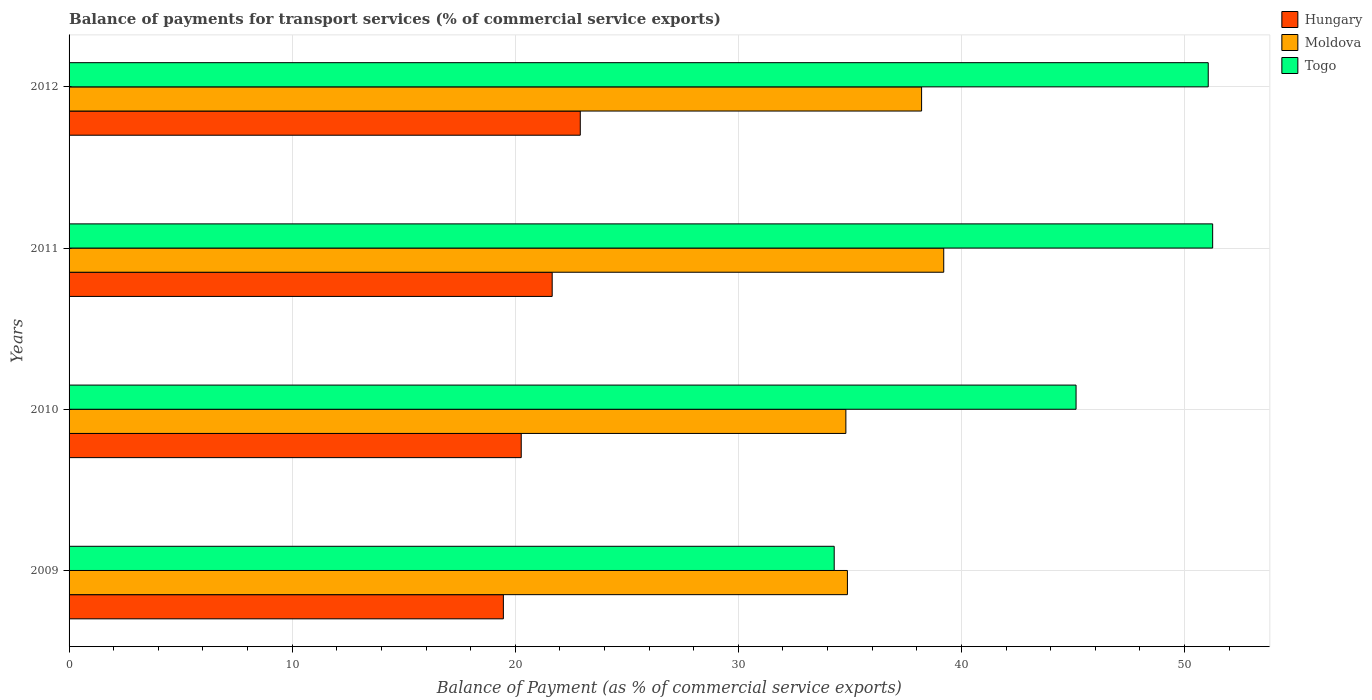How many different coloured bars are there?
Make the answer very short. 3. How many groups of bars are there?
Provide a short and direct response. 4. Are the number of bars per tick equal to the number of legend labels?
Your answer should be very brief. Yes. What is the label of the 1st group of bars from the top?
Your answer should be very brief. 2012. What is the balance of payments for transport services in Moldova in 2011?
Give a very brief answer. 39.21. Across all years, what is the maximum balance of payments for transport services in Hungary?
Offer a very short reply. 22.92. Across all years, what is the minimum balance of payments for transport services in Hungary?
Offer a very short reply. 19.47. In which year was the balance of payments for transport services in Hungary maximum?
Offer a very short reply. 2012. In which year was the balance of payments for transport services in Togo minimum?
Offer a terse response. 2009. What is the total balance of payments for transport services in Togo in the graph?
Provide a short and direct response. 181.76. What is the difference between the balance of payments for transport services in Togo in 2009 and that in 2011?
Keep it short and to the point. -16.96. What is the difference between the balance of payments for transport services in Hungary in 2010 and the balance of payments for transport services in Togo in 2012?
Your answer should be compact. -30.8. What is the average balance of payments for transport services in Togo per year?
Ensure brevity in your answer.  45.44. In the year 2009, what is the difference between the balance of payments for transport services in Hungary and balance of payments for transport services in Togo?
Your answer should be compact. -14.83. In how many years, is the balance of payments for transport services in Togo greater than 30 %?
Give a very brief answer. 4. What is the ratio of the balance of payments for transport services in Moldova in 2011 to that in 2012?
Offer a very short reply. 1.03. Is the difference between the balance of payments for transport services in Hungary in 2009 and 2012 greater than the difference between the balance of payments for transport services in Togo in 2009 and 2012?
Provide a succinct answer. Yes. What is the difference between the highest and the second highest balance of payments for transport services in Togo?
Make the answer very short. 0.2. What is the difference between the highest and the lowest balance of payments for transport services in Moldova?
Give a very brief answer. 4.39. In how many years, is the balance of payments for transport services in Togo greater than the average balance of payments for transport services in Togo taken over all years?
Ensure brevity in your answer.  2. Is the sum of the balance of payments for transport services in Hungary in 2010 and 2011 greater than the maximum balance of payments for transport services in Moldova across all years?
Your answer should be very brief. Yes. What does the 3rd bar from the top in 2010 represents?
Provide a short and direct response. Hungary. What does the 2nd bar from the bottom in 2012 represents?
Your answer should be compact. Moldova. Is it the case that in every year, the sum of the balance of payments for transport services in Moldova and balance of payments for transport services in Togo is greater than the balance of payments for transport services in Hungary?
Your answer should be very brief. Yes. Are all the bars in the graph horizontal?
Give a very brief answer. Yes. Does the graph contain any zero values?
Provide a short and direct response. No. Where does the legend appear in the graph?
Keep it short and to the point. Top right. How many legend labels are there?
Your answer should be compact. 3. What is the title of the graph?
Offer a very short reply. Balance of payments for transport services (% of commercial service exports). Does "Tuvalu" appear as one of the legend labels in the graph?
Your answer should be very brief. No. What is the label or title of the X-axis?
Offer a very short reply. Balance of Payment (as % of commercial service exports). What is the label or title of the Y-axis?
Make the answer very short. Years. What is the Balance of Payment (as % of commercial service exports) of Hungary in 2009?
Provide a short and direct response. 19.47. What is the Balance of Payment (as % of commercial service exports) in Moldova in 2009?
Your response must be concise. 34.89. What is the Balance of Payment (as % of commercial service exports) of Togo in 2009?
Offer a terse response. 34.3. What is the Balance of Payment (as % of commercial service exports) of Hungary in 2010?
Offer a terse response. 20.27. What is the Balance of Payment (as % of commercial service exports) in Moldova in 2010?
Your answer should be compact. 34.82. What is the Balance of Payment (as % of commercial service exports) of Togo in 2010?
Your answer should be compact. 45.14. What is the Balance of Payment (as % of commercial service exports) in Hungary in 2011?
Ensure brevity in your answer.  21.66. What is the Balance of Payment (as % of commercial service exports) in Moldova in 2011?
Your answer should be compact. 39.21. What is the Balance of Payment (as % of commercial service exports) of Togo in 2011?
Provide a short and direct response. 51.26. What is the Balance of Payment (as % of commercial service exports) in Hungary in 2012?
Your response must be concise. 22.92. What is the Balance of Payment (as % of commercial service exports) in Moldova in 2012?
Give a very brief answer. 38.22. What is the Balance of Payment (as % of commercial service exports) of Togo in 2012?
Keep it short and to the point. 51.06. Across all years, what is the maximum Balance of Payment (as % of commercial service exports) of Hungary?
Provide a short and direct response. 22.92. Across all years, what is the maximum Balance of Payment (as % of commercial service exports) in Moldova?
Ensure brevity in your answer.  39.21. Across all years, what is the maximum Balance of Payment (as % of commercial service exports) of Togo?
Make the answer very short. 51.26. Across all years, what is the minimum Balance of Payment (as % of commercial service exports) of Hungary?
Provide a short and direct response. 19.47. Across all years, what is the minimum Balance of Payment (as % of commercial service exports) in Moldova?
Ensure brevity in your answer.  34.82. Across all years, what is the minimum Balance of Payment (as % of commercial service exports) in Togo?
Your answer should be very brief. 34.3. What is the total Balance of Payment (as % of commercial service exports) of Hungary in the graph?
Keep it short and to the point. 84.31. What is the total Balance of Payment (as % of commercial service exports) of Moldova in the graph?
Ensure brevity in your answer.  147.13. What is the total Balance of Payment (as % of commercial service exports) of Togo in the graph?
Provide a succinct answer. 181.76. What is the difference between the Balance of Payment (as % of commercial service exports) in Hungary in 2009 and that in 2010?
Your answer should be compact. -0.8. What is the difference between the Balance of Payment (as % of commercial service exports) of Moldova in 2009 and that in 2010?
Your answer should be compact. 0.07. What is the difference between the Balance of Payment (as % of commercial service exports) of Togo in 2009 and that in 2010?
Offer a terse response. -10.84. What is the difference between the Balance of Payment (as % of commercial service exports) of Hungary in 2009 and that in 2011?
Make the answer very short. -2.19. What is the difference between the Balance of Payment (as % of commercial service exports) in Moldova in 2009 and that in 2011?
Provide a short and direct response. -4.32. What is the difference between the Balance of Payment (as % of commercial service exports) of Togo in 2009 and that in 2011?
Your response must be concise. -16.96. What is the difference between the Balance of Payment (as % of commercial service exports) of Hungary in 2009 and that in 2012?
Provide a short and direct response. -3.45. What is the difference between the Balance of Payment (as % of commercial service exports) in Moldova in 2009 and that in 2012?
Offer a terse response. -3.33. What is the difference between the Balance of Payment (as % of commercial service exports) in Togo in 2009 and that in 2012?
Ensure brevity in your answer.  -16.77. What is the difference between the Balance of Payment (as % of commercial service exports) in Hungary in 2010 and that in 2011?
Your answer should be very brief. -1.39. What is the difference between the Balance of Payment (as % of commercial service exports) of Moldova in 2010 and that in 2011?
Keep it short and to the point. -4.39. What is the difference between the Balance of Payment (as % of commercial service exports) in Togo in 2010 and that in 2011?
Keep it short and to the point. -6.12. What is the difference between the Balance of Payment (as % of commercial service exports) of Hungary in 2010 and that in 2012?
Give a very brief answer. -2.65. What is the difference between the Balance of Payment (as % of commercial service exports) of Moldova in 2010 and that in 2012?
Give a very brief answer. -3.39. What is the difference between the Balance of Payment (as % of commercial service exports) of Togo in 2010 and that in 2012?
Offer a terse response. -5.92. What is the difference between the Balance of Payment (as % of commercial service exports) of Hungary in 2011 and that in 2012?
Offer a very short reply. -1.26. What is the difference between the Balance of Payment (as % of commercial service exports) of Togo in 2011 and that in 2012?
Provide a short and direct response. 0.2. What is the difference between the Balance of Payment (as % of commercial service exports) in Hungary in 2009 and the Balance of Payment (as % of commercial service exports) in Moldova in 2010?
Provide a succinct answer. -15.35. What is the difference between the Balance of Payment (as % of commercial service exports) in Hungary in 2009 and the Balance of Payment (as % of commercial service exports) in Togo in 2010?
Offer a terse response. -25.67. What is the difference between the Balance of Payment (as % of commercial service exports) of Moldova in 2009 and the Balance of Payment (as % of commercial service exports) of Togo in 2010?
Ensure brevity in your answer.  -10.25. What is the difference between the Balance of Payment (as % of commercial service exports) in Hungary in 2009 and the Balance of Payment (as % of commercial service exports) in Moldova in 2011?
Your answer should be compact. -19.74. What is the difference between the Balance of Payment (as % of commercial service exports) in Hungary in 2009 and the Balance of Payment (as % of commercial service exports) in Togo in 2011?
Your answer should be compact. -31.79. What is the difference between the Balance of Payment (as % of commercial service exports) of Moldova in 2009 and the Balance of Payment (as % of commercial service exports) of Togo in 2011?
Give a very brief answer. -16.37. What is the difference between the Balance of Payment (as % of commercial service exports) in Hungary in 2009 and the Balance of Payment (as % of commercial service exports) in Moldova in 2012?
Your response must be concise. -18.75. What is the difference between the Balance of Payment (as % of commercial service exports) in Hungary in 2009 and the Balance of Payment (as % of commercial service exports) in Togo in 2012?
Offer a terse response. -31.6. What is the difference between the Balance of Payment (as % of commercial service exports) in Moldova in 2009 and the Balance of Payment (as % of commercial service exports) in Togo in 2012?
Provide a succinct answer. -16.17. What is the difference between the Balance of Payment (as % of commercial service exports) of Hungary in 2010 and the Balance of Payment (as % of commercial service exports) of Moldova in 2011?
Provide a succinct answer. -18.94. What is the difference between the Balance of Payment (as % of commercial service exports) of Hungary in 2010 and the Balance of Payment (as % of commercial service exports) of Togo in 2011?
Your answer should be compact. -30.99. What is the difference between the Balance of Payment (as % of commercial service exports) in Moldova in 2010 and the Balance of Payment (as % of commercial service exports) in Togo in 2011?
Provide a short and direct response. -16.44. What is the difference between the Balance of Payment (as % of commercial service exports) in Hungary in 2010 and the Balance of Payment (as % of commercial service exports) in Moldova in 2012?
Make the answer very short. -17.95. What is the difference between the Balance of Payment (as % of commercial service exports) in Hungary in 2010 and the Balance of Payment (as % of commercial service exports) in Togo in 2012?
Ensure brevity in your answer.  -30.8. What is the difference between the Balance of Payment (as % of commercial service exports) in Moldova in 2010 and the Balance of Payment (as % of commercial service exports) in Togo in 2012?
Offer a very short reply. -16.24. What is the difference between the Balance of Payment (as % of commercial service exports) of Hungary in 2011 and the Balance of Payment (as % of commercial service exports) of Moldova in 2012?
Provide a succinct answer. -16.56. What is the difference between the Balance of Payment (as % of commercial service exports) of Hungary in 2011 and the Balance of Payment (as % of commercial service exports) of Togo in 2012?
Offer a very short reply. -29.41. What is the difference between the Balance of Payment (as % of commercial service exports) in Moldova in 2011 and the Balance of Payment (as % of commercial service exports) in Togo in 2012?
Your answer should be very brief. -11.86. What is the average Balance of Payment (as % of commercial service exports) of Hungary per year?
Your answer should be compact. 21.08. What is the average Balance of Payment (as % of commercial service exports) of Moldova per year?
Your answer should be compact. 36.78. What is the average Balance of Payment (as % of commercial service exports) in Togo per year?
Keep it short and to the point. 45.44. In the year 2009, what is the difference between the Balance of Payment (as % of commercial service exports) of Hungary and Balance of Payment (as % of commercial service exports) of Moldova?
Offer a very short reply. -15.42. In the year 2009, what is the difference between the Balance of Payment (as % of commercial service exports) of Hungary and Balance of Payment (as % of commercial service exports) of Togo?
Your response must be concise. -14.83. In the year 2009, what is the difference between the Balance of Payment (as % of commercial service exports) in Moldova and Balance of Payment (as % of commercial service exports) in Togo?
Offer a terse response. 0.59. In the year 2010, what is the difference between the Balance of Payment (as % of commercial service exports) in Hungary and Balance of Payment (as % of commercial service exports) in Moldova?
Make the answer very short. -14.55. In the year 2010, what is the difference between the Balance of Payment (as % of commercial service exports) of Hungary and Balance of Payment (as % of commercial service exports) of Togo?
Keep it short and to the point. -24.87. In the year 2010, what is the difference between the Balance of Payment (as % of commercial service exports) of Moldova and Balance of Payment (as % of commercial service exports) of Togo?
Provide a succinct answer. -10.32. In the year 2011, what is the difference between the Balance of Payment (as % of commercial service exports) of Hungary and Balance of Payment (as % of commercial service exports) of Moldova?
Keep it short and to the point. -17.55. In the year 2011, what is the difference between the Balance of Payment (as % of commercial service exports) of Hungary and Balance of Payment (as % of commercial service exports) of Togo?
Your answer should be compact. -29.61. In the year 2011, what is the difference between the Balance of Payment (as % of commercial service exports) in Moldova and Balance of Payment (as % of commercial service exports) in Togo?
Your response must be concise. -12.05. In the year 2012, what is the difference between the Balance of Payment (as % of commercial service exports) in Hungary and Balance of Payment (as % of commercial service exports) in Moldova?
Provide a short and direct response. -15.3. In the year 2012, what is the difference between the Balance of Payment (as % of commercial service exports) of Hungary and Balance of Payment (as % of commercial service exports) of Togo?
Give a very brief answer. -28.15. In the year 2012, what is the difference between the Balance of Payment (as % of commercial service exports) in Moldova and Balance of Payment (as % of commercial service exports) in Togo?
Offer a very short reply. -12.85. What is the ratio of the Balance of Payment (as % of commercial service exports) of Hungary in 2009 to that in 2010?
Make the answer very short. 0.96. What is the ratio of the Balance of Payment (as % of commercial service exports) in Togo in 2009 to that in 2010?
Your response must be concise. 0.76. What is the ratio of the Balance of Payment (as % of commercial service exports) of Hungary in 2009 to that in 2011?
Your answer should be compact. 0.9. What is the ratio of the Balance of Payment (as % of commercial service exports) of Moldova in 2009 to that in 2011?
Offer a very short reply. 0.89. What is the ratio of the Balance of Payment (as % of commercial service exports) in Togo in 2009 to that in 2011?
Provide a short and direct response. 0.67. What is the ratio of the Balance of Payment (as % of commercial service exports) in Hungary in 2009 to that in 2012?
Offer a terse response. 0.85. What is the ratio of the Balance of Payment (as % of commercial service exports) of Moldova in 2009 to that in 2012?
Ensure brevity in your answer.  0.91. What is the ratio of the Balance of Payment (as % of commercial service exports) in Togo in 2009 to that in 2012?
Give a very brief answer. 0.67. What is the ratio of the Balance of Payment (as % of commercial service exports) of Hungary in 2010 to that in 2011?
Make the answer very short. 0.94. What is the ratio of the Balance of Payment (as % of commercial service exports) of Moldova in 2010 to that in 2011?
Your answer should be very brief. 0.89. What is the ratio of the Balance of Payment (as % of commercial service exports) of Togo in 2010 to that in 2011?
Make the answer very short. 0.88. What is the ratio of the Balance of Payment (as % of commercial service exports) in Hungary in 2010 to that in 2012?
Provide a short and direct response. 0.88. What is the ratio of the Balance of Payment (as % of commercial service exports) in Moldova in 2010 to that in 2012?
Make the answer very short. 0.91. What is the ratio of the Balance of Payment (as % of commercial service exports) of Togo in 2010 to that in 2012?
Provide a succinct answer. 0.88. What is the ratio of the Balance of Payment (as % of commercial service exports) of Hungary in 2011 to that in 2012?
Ensure brevity in your answer.  0.94. What is the difference between the highest and the second highest Balance of Payment (as % of commercial service exports) in Hungary?
Provide a succinct answer. 1.26. What is the difference between the highest and the second highest Balance of Payment (as % of commercial service exports) in Togo?
Provide a succinct answer. 0.2. What is the difference between the highest and the lowest Balance of Payment (as % of commercial service exports) of Hungary?
Provide a succinct answer. 3.45. What is the difference between the highest and the lowest Balance of Payment (as % of commercial service exports) of Moldova?
Your answer should be very brief. 4.39. What is the difference between the highest and the lowest Balance of Payment (as % of commercial service exports) in Togo?
Ensure brevity in your answer.  16.96. 